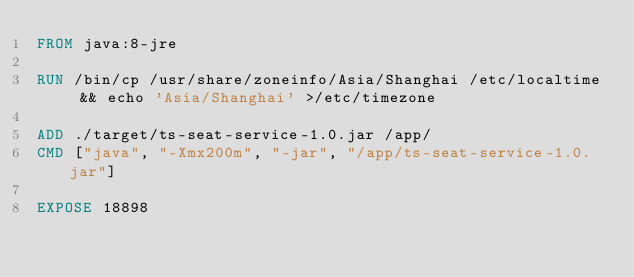<code> <loc_0><loc_0><loc_500><loc_500><_Dockerfile_>FROM java:8-jre

RUN /bin/cp /usr/share/zoneinfo/Asia/Shanghai /etc/localtime && echo 'Asia/Shanghai' >/etc/timezone

ADD ./target/ts-seat-service-1.0.jar /app/
CMD ["java", "-Xmx200m", "-jar", "/app/ts-seat-service-1.0.jar"]

EXPOSE 18898</code> 